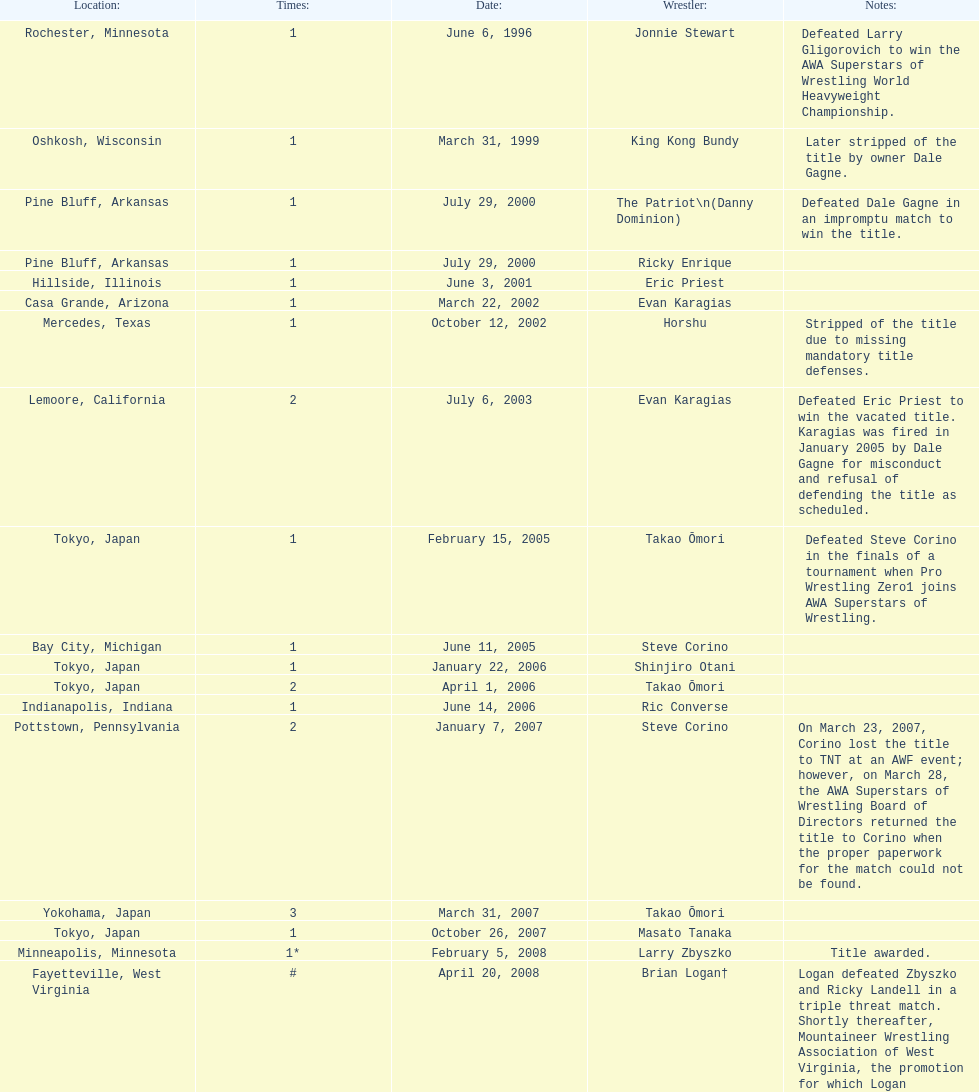What are the number of matches that happened in japan? 5. 